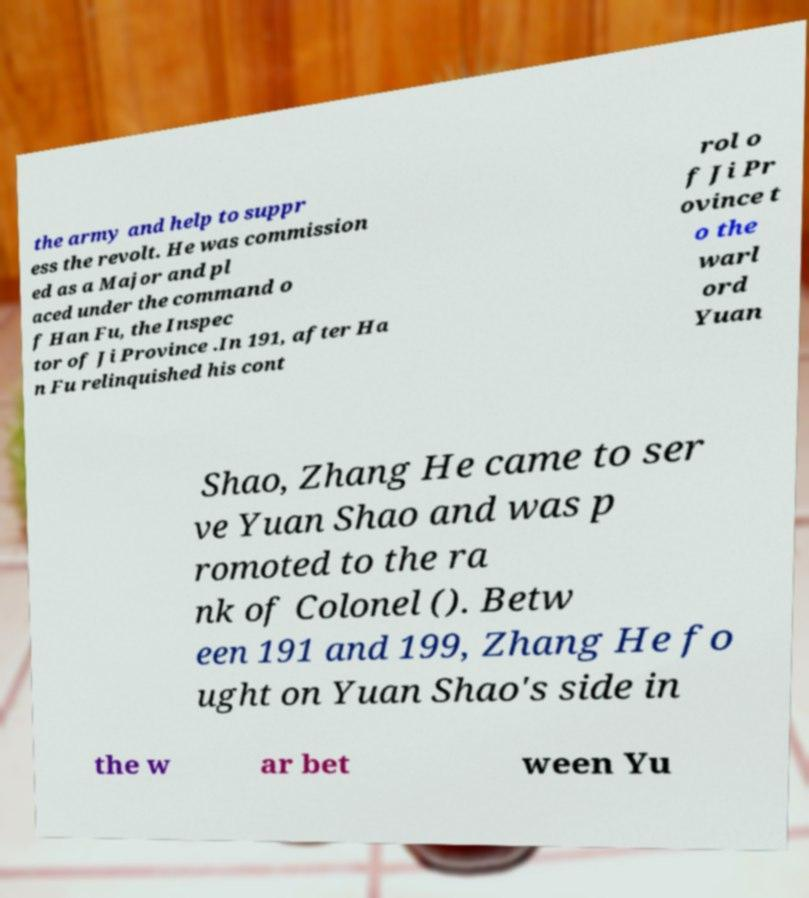Please read and relay the text visible in this image. What does it say? the army and help to suppr ess the revolt. He was commission ed as a Major and pl aced under the command o f Han Fu, the Inspec tor of Ji Province .In 191, after Ha n Fu relinquished his cont rol o f Ji Pr ovince t o the warl ord Yuan Shao, Zhang He came to ser ve Yuan Shao and was p romoted to the ra nk of Colonel (). Betw een 191 and 199, Zhang He fo ught on Yuan Shao's side in the w ar bet ween Yu 